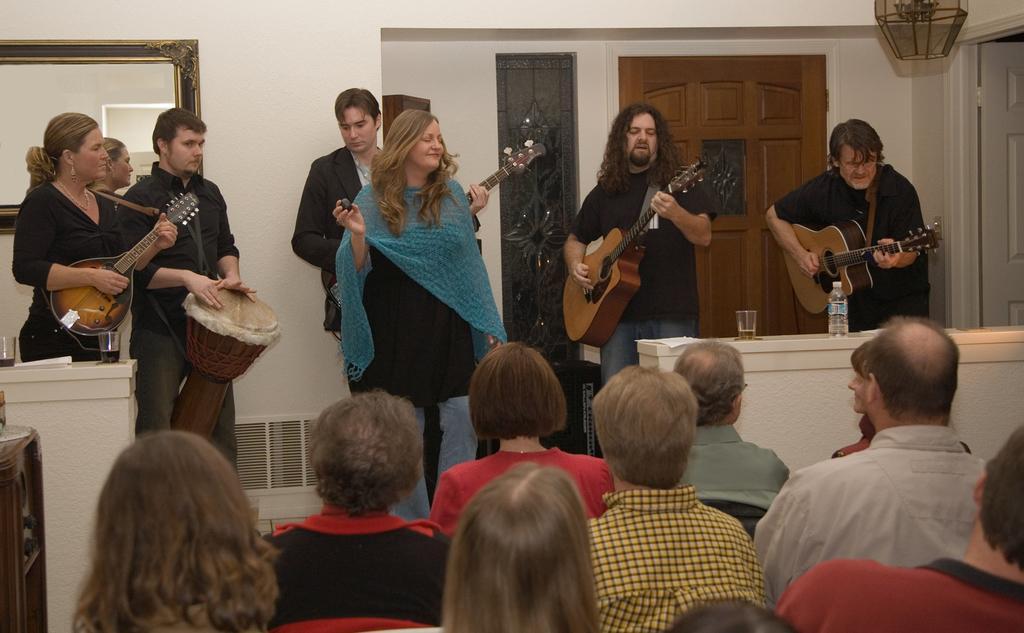Could you give a brief overview of what you see in this image? In the image we can see there are lot of people who are standing and people are sitting and watching them and the men are holding guitar in their hand and drum. 